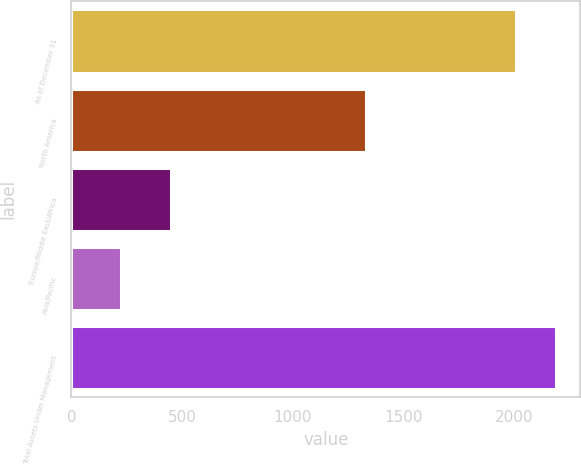<chart> <loc_0><loc_0><loc_500><loc_500><bar_chart><fcel>As of December 31<fcel>North America<fcel>Europe/Middle East/Africa<fcel>Asia/Pacific<fcel>Total Assets Under Management<nl><fcel>2010<fcel>1332<fcel>452<fcel>226<fcel>2188.4<nl></chart> 